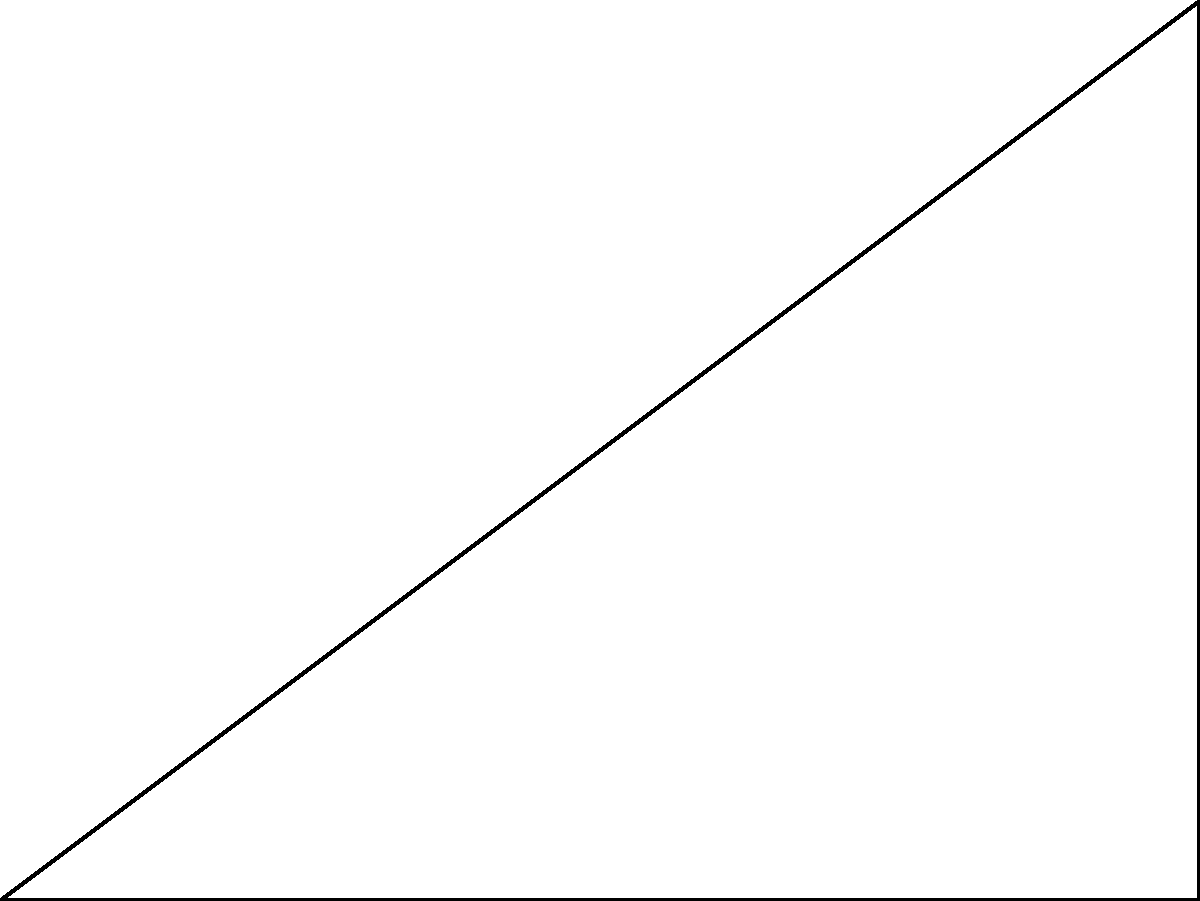Given a profile view of a coastal cliff in the Amalfi Coast, where point A represents the base of the cliff at sea level, point B is 4 units horizontally from A, and point C is the top of the cliff, 3 units vertically above B, what is the angle $\theta$ of the cliff face with respect to the horizontal? To determine the angle of the cliff face, we can use trigonometry:

1. The cliff face forms a right triangle ABC, where:
   - AB is the horizontal distance (4 units)
   - BC is the vertical height (3 units)
   - AC is the cliff face (hypotenuse)

2. We need to find the angle $\theta$ between AB and AC.

3. We can use the arctangent function (tan^(-1)) to calculate this angle:

   $\theta = \tan^{-1}(\frac{\text{opposite}}{\text{adjacent}}) = \tan^{-1}(\frac{BC}{AB})$

4. Substituting the values:

   $\theta = \tan^{-1}(\frac{3}{4})$

5. Calculate:

   $\theta \approx 36.87°$

6. Round to the nearest degree:

   $\theta \approx 37°$
Answer: $37°$ 